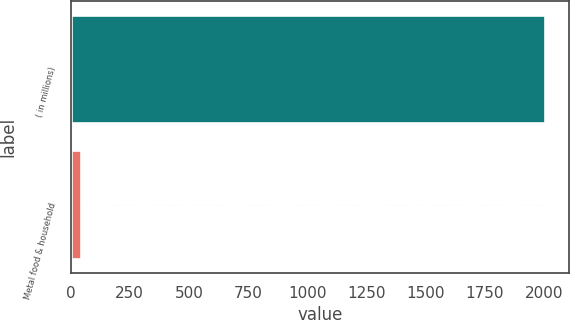<chart> <loc_0><loc_0><loc_500><loc_500><bar_chart><fcel>( in millions)<fcel>Metal food & household<nl><fcel>2007<fcel>44.2<nl></chart> 